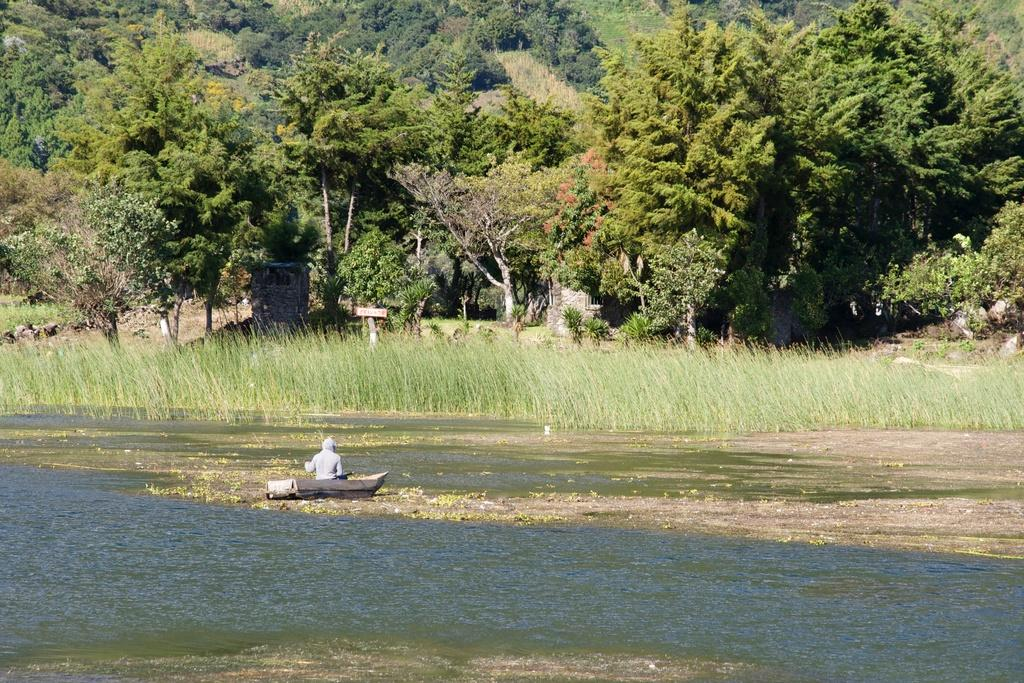What is the main subject of the image? The main subject of the image is a boat. Who or what is inside the boat? A person is sitting in the boat. What type of environment is visible in the image? There is water, grass, and trees visible in the image. What historical event is being commemorated by the person in the boat? There is no indication of a historical event being commemorated in the image. The person is simply sitting in the boat. 